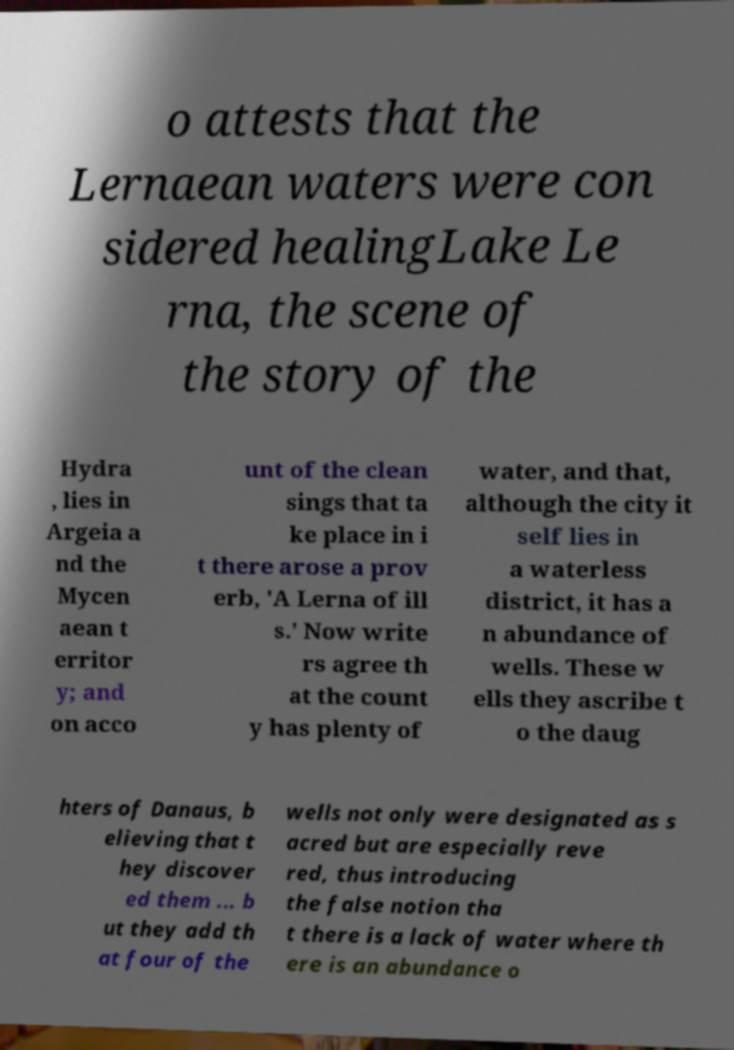Could you assist in decoding the text presented in this image and type it out clearly? o attests that the Lernaean waters were con sidered healingLake Le rna, the scene of the story of the Hydra , lies in Argeia a nd the Mycen aean t erritor y; and on acco unt of the clean sings that ta ke place in i t there arose a prov erb, 'A Lerna of ill s.' Now write rs agree th at the count y has plenty of water, and that, although the city it self lies in a waterless district, it has a n abundance of wells. These w ells they ascribe t o the daug hters of Danaus, b elieving that t hey discover ed them ... b ut they add th at four of the wells not only were designated as s acred but are especially reve red, thus introducing the false notion tha t there is a lack of water where th ere is an abundance o 